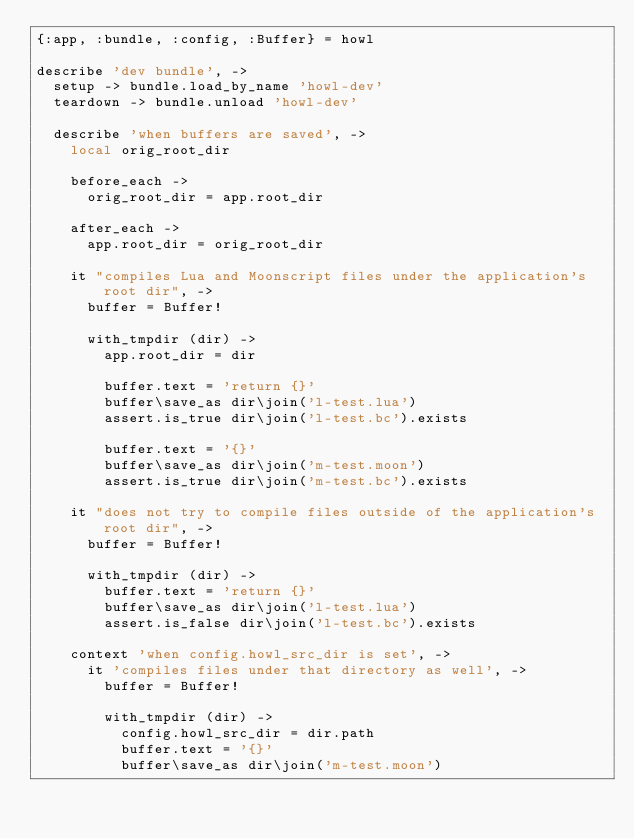<code> <loc_0><loc_0><loc_500><loc_500><_MoonScript_>{:app, :bundle, :config, :Buffer} = howl

describe 'dev bundle', ->
  setup -> bundle.load_by_name 'howl-dev'
  teardown -> bundle.unload 'howl-dev'

  describe 'when buffers are saved', ->
    local orig_root_dir

    before_each ->
      orig_root_dir = app.root_dir

    after_each ->
      app.root_dir = orig_root_dir

    it "compiles Lua and Moonscript files under the application's root dir", ->
      buffer = Buffer!

      with_tmpdir (dir) ->
        app.root_dir = dir

        buffer.text = 'return {}'
        buffer\save_as dir\join('l-test.lua')
        assert.is_true dir\join('l-test.bc').exists

        buffer.text = '{}'
        buffer\save_as dir\join('m-test.moon')
        assert.is_true dir\join('m-test.bc').exists

    it "does not try to compile files outside of the application's root dir", ->
      buffer = Buffer!

      with_tmpdir (dir) ->
        buffer.text = 'return {}'
        buffer\save_as dir\join('l-test.lua')
        assert.is_false dir\join('l-test.bc').exists

    context 'when config.howl_src_dir is set', ->
      it 'compiles files under that directory as well', ->
        buffer = Buffer!

        with_tmpdir (dir) ->
          config.howl_src_dir = dir.path
          buffer.text = '{}'
          buffer\save_as dir\join('m-test.moon')</code> 